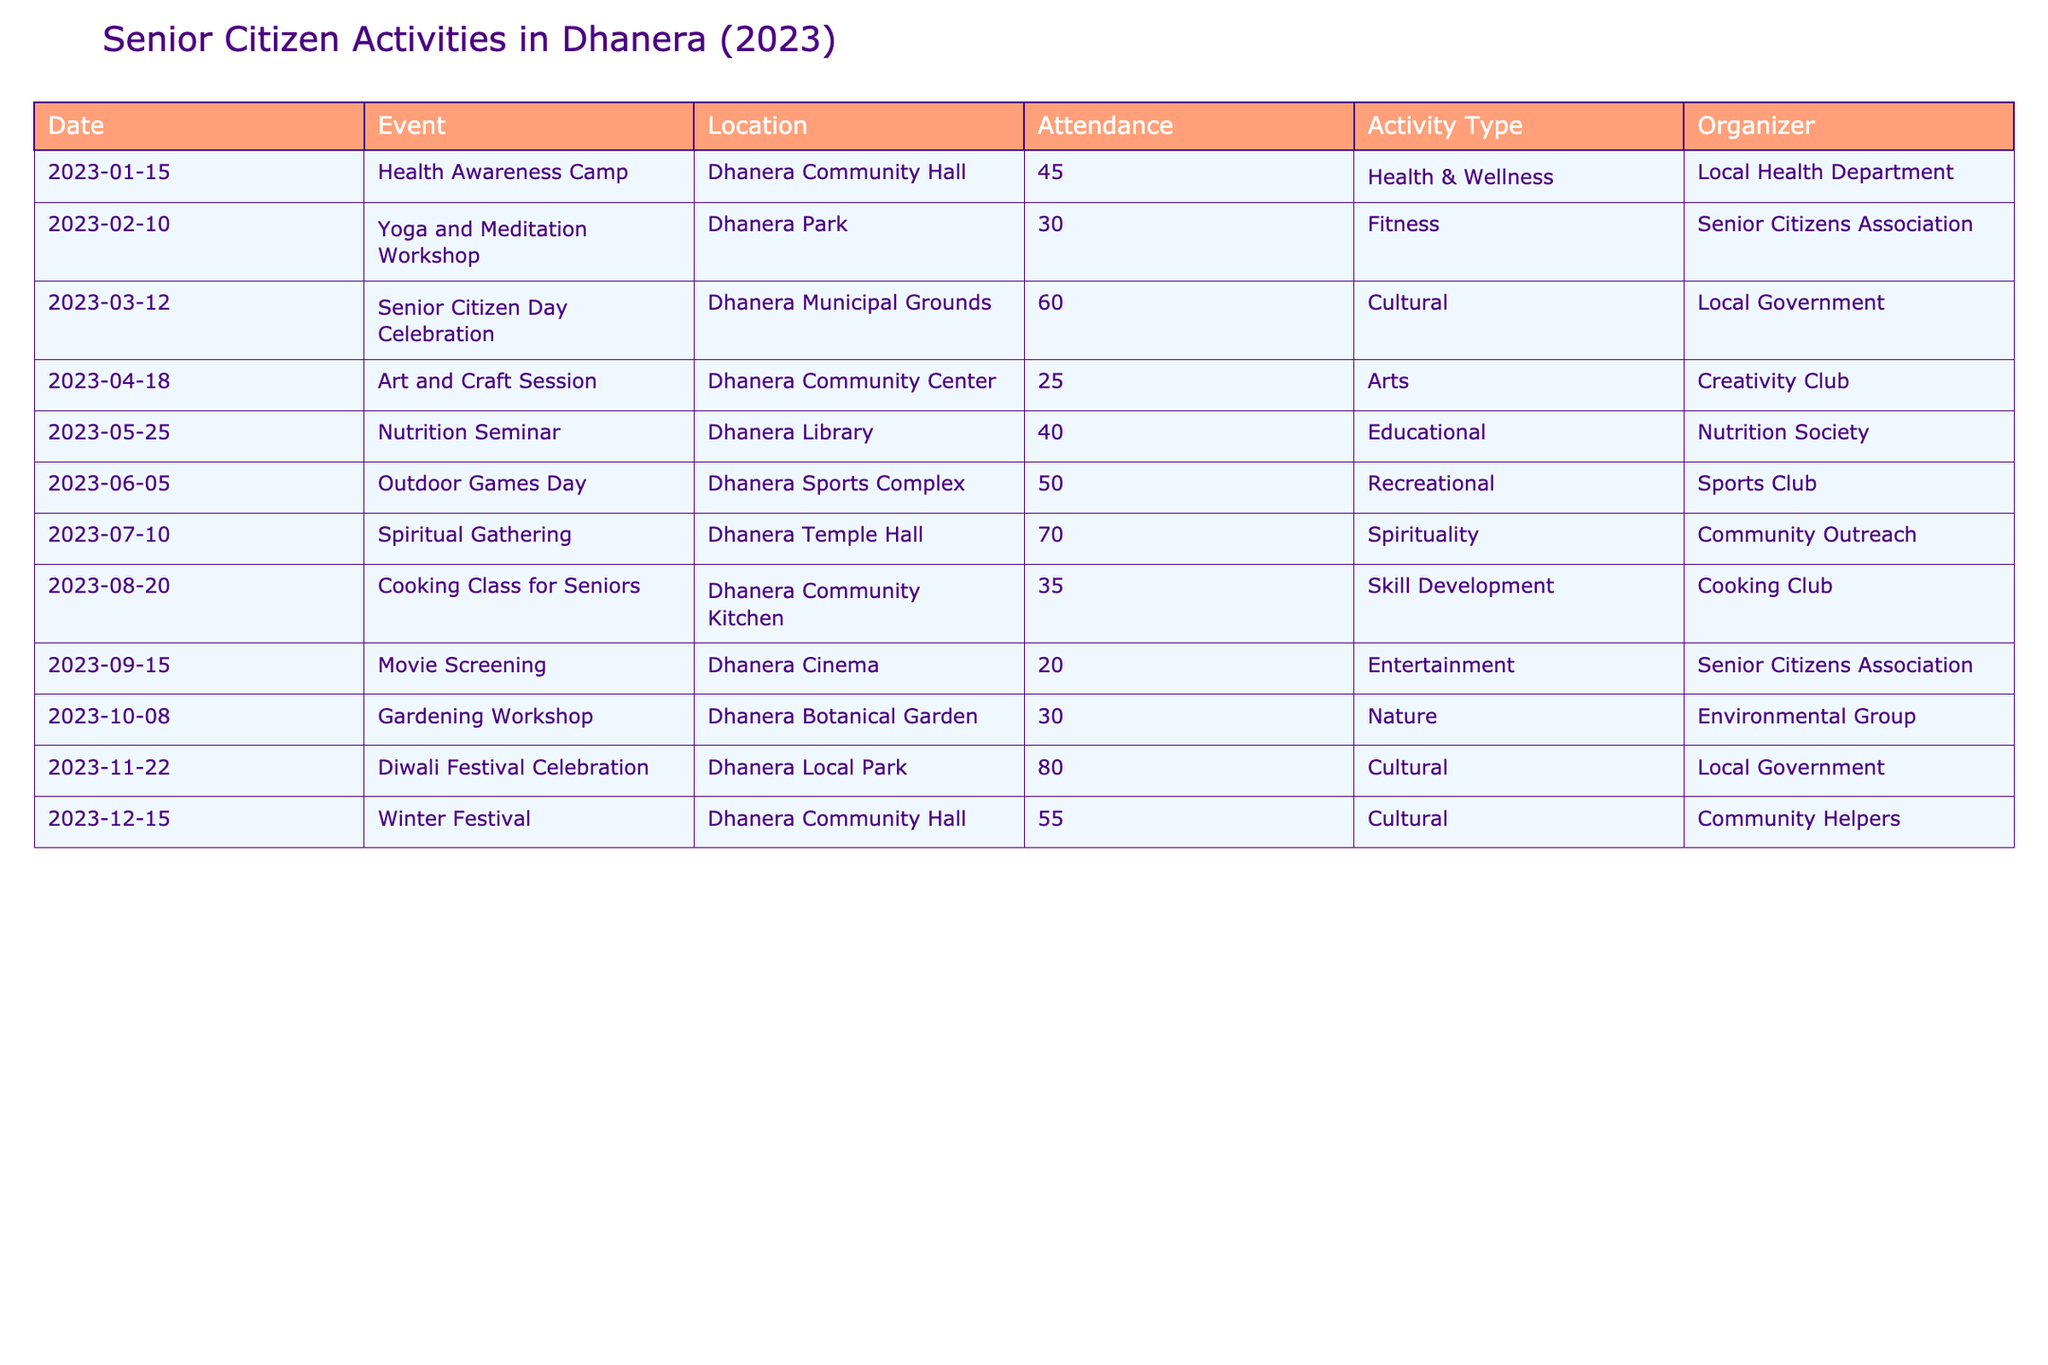What was the attendance at the Diwali Festival Celebration? The attendance for the Diwali Festival Celebration, which took place on November 22, is recorded as 80 in the table.
Answer: 80 Which event had the lowest attendance? The event with the lowest attendance is the Movie Screening on September 15, which had 20 attendees.
Answer: 20 What is the total attendance for all cultural events? The cultural events include Senior Citizen Day Celebration (60), Diwali Festival Celebration (80), and Winter Festival (55). Summing these gives 60 + 80 + 55 = 195.
Answer: 195 How many events were organized at the Dhanera Community Hall in 2023? The Dhanera Community Hall hosted two events: the Health Awareness Camp and the Winter Festival, which is a count of 2.
Answer: 2 Is the attendance at the Yoga and Meditation Workshop greater than at the Gardening Workshop? The Yoga and Meditation Workshop had an attendance of 30, while the Gardening Workshop also had an attendance of 30. Therefore, the attendance is the same, making this statement false.
Answer: No What is the average attendance for all events held in Dhanera? First, we sum the attendance: 45 + 30 + 60 + 25 + 40 + 50 + 70 + 35 + 20 + 30 + 80 + 55 = 600. There are 12 events, so we calculate the average: 600/12 = 50.
Answer: 50 Which activity type had the highest attendance overall? The Spirituality event, the Spiritual Gathering, had the highest attendance of 70.
Answer: Spirituality Was there a higher attendance at educational events or skill development events? The Nutrition Seminar (40) is the only educational event, and the Cooking Class for Seniors (35) is the only skill development event. Comparing them, educational attendance (40) is higher than skill development (35).
Answer: Yes How many more attendees were there at the Outdoor Games Day compared to the Art and Craft Session? Outdoor Games Day had 50 attendees and Art and Craft Session had 25 attendees, so the difference is 50 - 25 = 25.
Answer: 25 What percentage of attendees were present at the Health Awareness Camp compared to the total number of attendees across all events? The total attendance is 600, and the Health Awareness Camp had 45 attendees. Therefore, the percentage is (45/600) * 100 = 7.5%.
Answer: 7.5% 